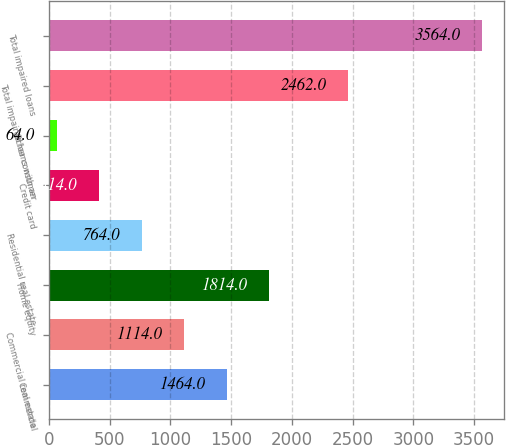<chart> <loc_0><loc_0><loc_500><loc_500><bar_chart><fcel>Commercial<fcel>Commercial real estate<fcel>Home equity<fcel>Residential real estate<fcel>Credit card<fcel>Other consumer<fcel>Total impaired loans with an<fcel>Total impaired loans<nl><fcel>1464<fcel>1114<fcel>1814<fcel>764<fcel>414<fcel>64<fcel>2462<fcel>3564<nl></chart> 